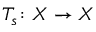<formula> <loc_0><loc_0><loc_500><loc_500>T _ { s } \colon X \to X</formula> 